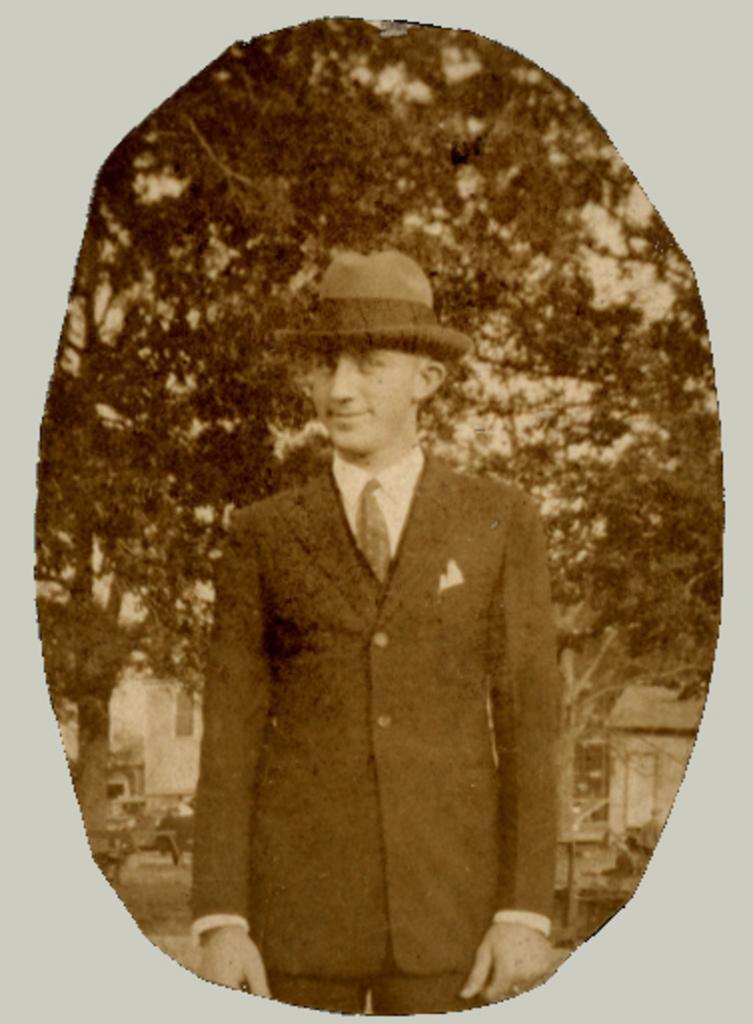Please provide a concise description of this image. In this image I can see the person wearing the blazer, shirt, tie and the hat. In the background I can see the trees and the house. And this is a black and white image. 